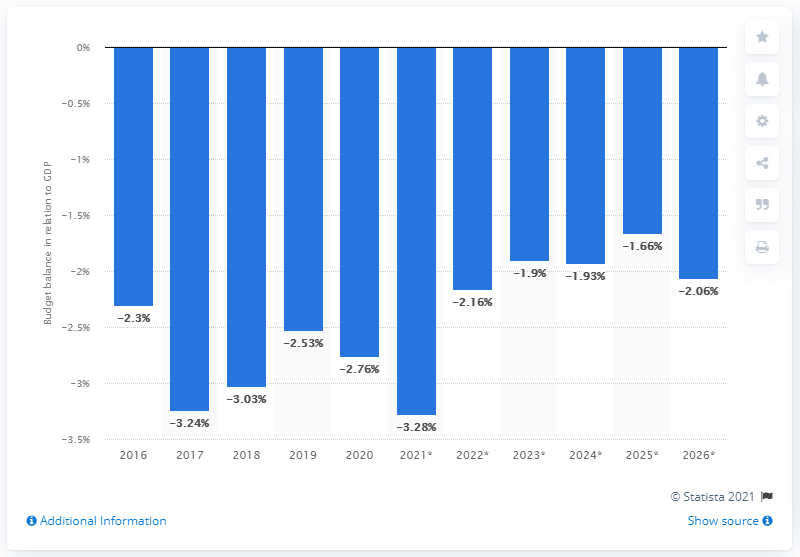Identify some key points in this picture. Ethiopia's budget balance last year was relative to its GDP in 2020. 